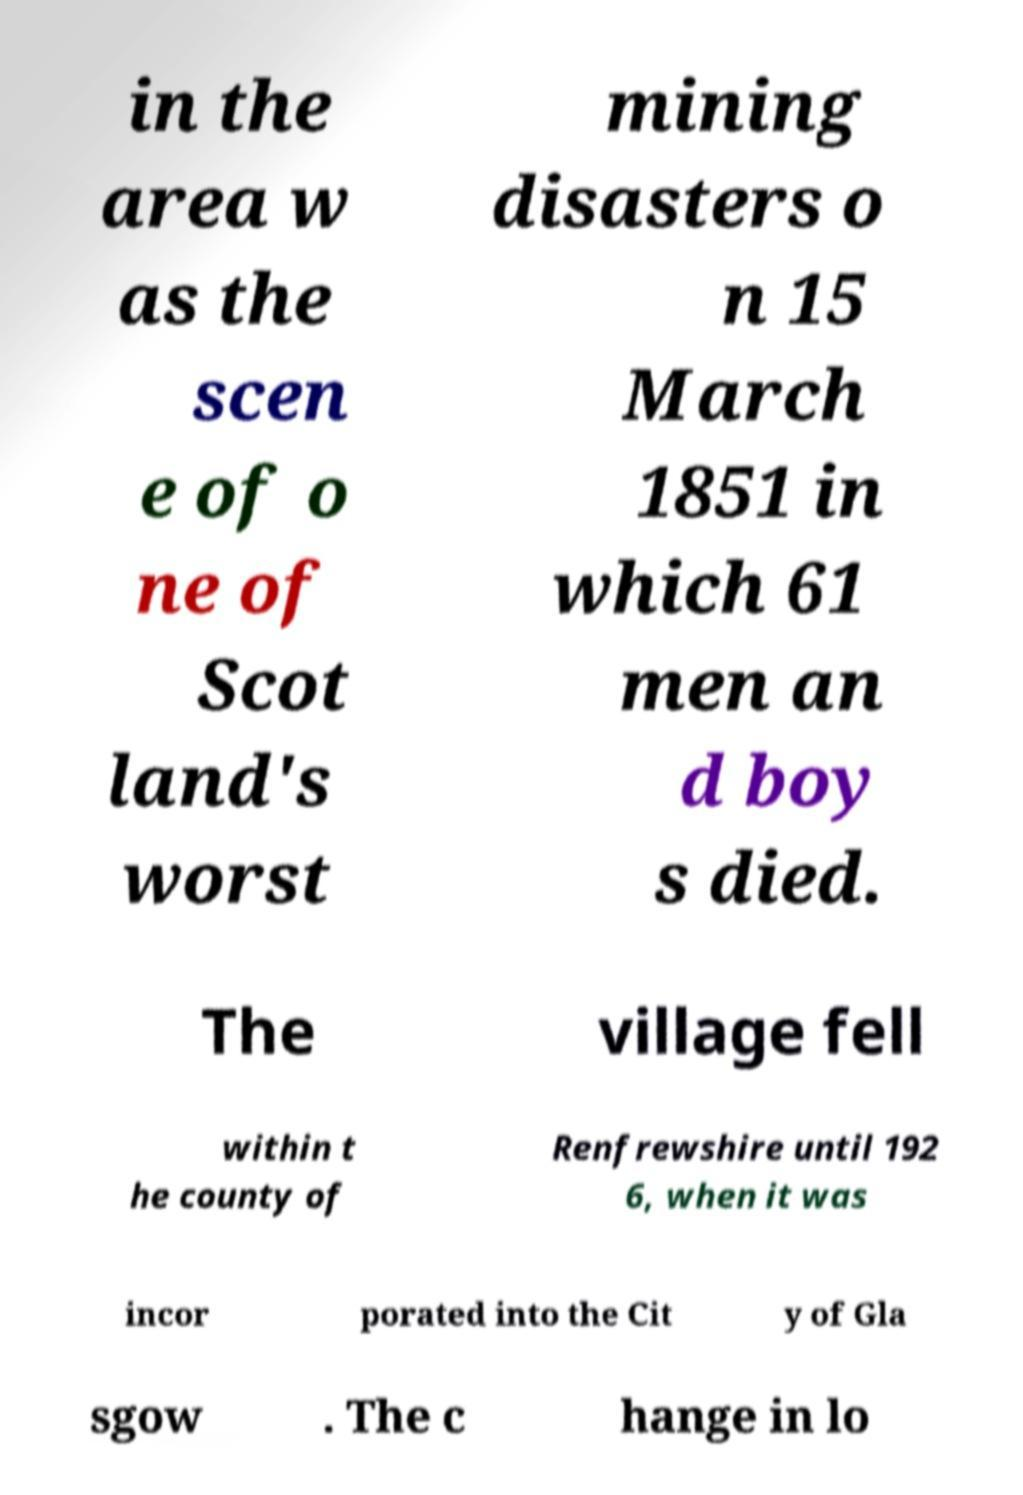Can you accurately transcribe the text from the provided image for me? in the area w as the scen e of o ne of Scot land's worst mining disasters o n 15 March 1851 in which 61 men an d boy s died. The village fell within t he county of Renfrewshire until 192 6, when it was incor porated into the Cit y of Gla sgow . The c hange in lo 